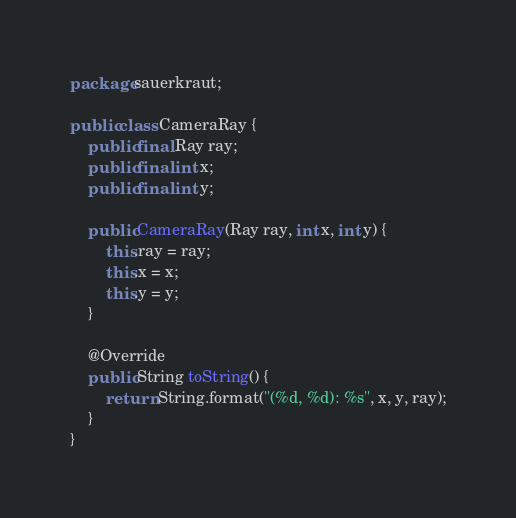<code> <loc_0><loc_0><loc_500><loc_500><_Java_>package sauerkraut;

public class CameraRay {
    public final Ray ray;
    public final int x;
    public final int y;

    public CameraRay(Ray ray, int x, int y) {
        this.ray = ray;
        this.x = x;
        this.y = y;
    }

    @Override
    public String toString() {
        return String.format("(%d, %d): %s", x, y, ray);
    }
}
</code> 